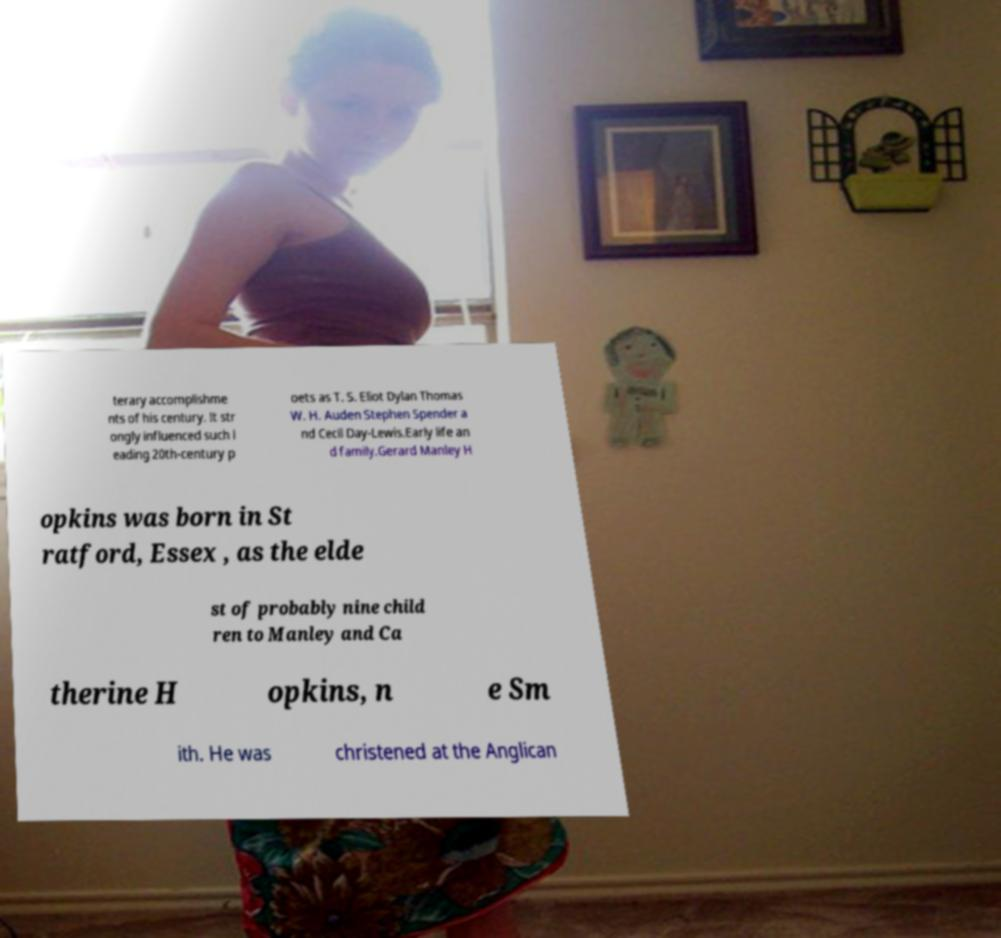Can you accurately transcribe the text from the provided image for me? terary accomplishme nts of his century. It str ongly influenced such l eading 20th-century p oets as T. S. Eliot Dylan Thomas W. H. Auden Stephen Spender a nd Cecil Day-Lewis.Early life an d family.Gerard Manley H opkins was born in St ratford, Essex , as the elde st of probably nine child ren to Manley and Ca therine H opkins, n e Sm ith. He was christened at the Anglican 